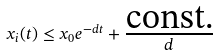<formula> <loc_0><loc_0><loc_500><loc_500>x _ { i } ( t ) \leq x _ { 0 } e ^ { - d t } + \frac { \text {const.} } { d }</formula> 